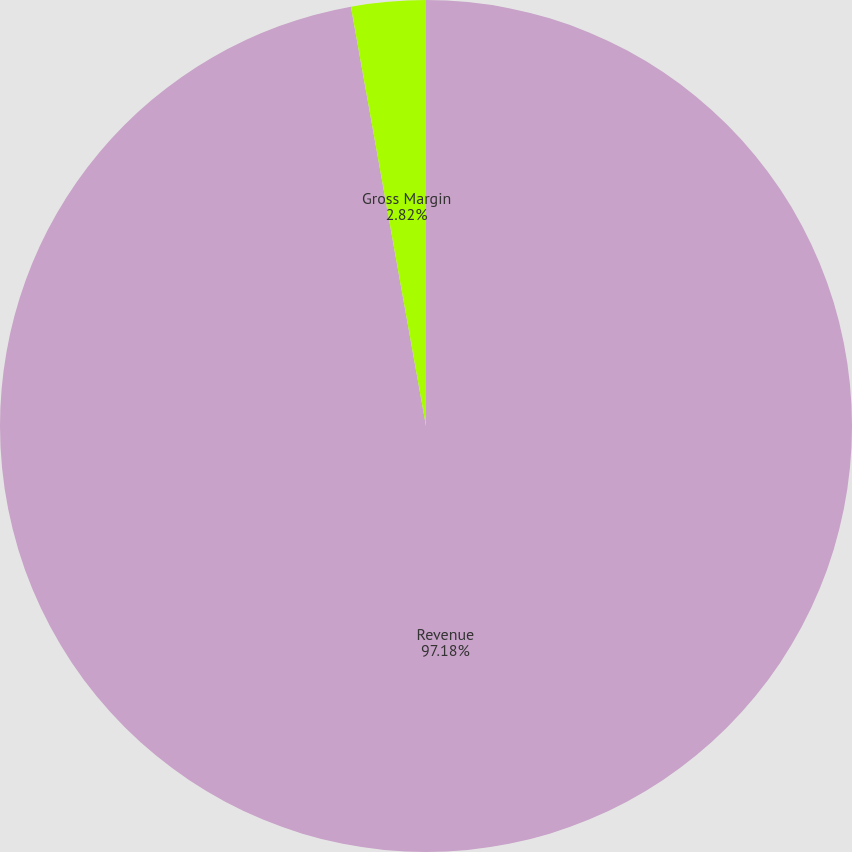<chart> <loc_0><loc_0><loc_500><loc_500><pie_chart><fcel>Revenue<fcel>Gross Margin<nl><fcel>97.18%<fcel>2.82%<nl></chart> 